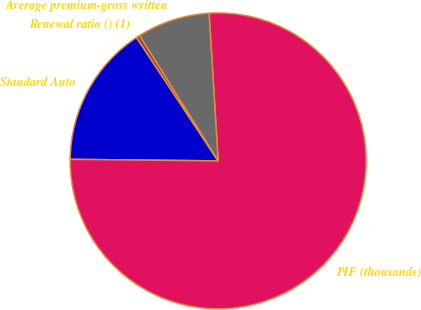Convert chart. <chart><loc_0><loc_0><loc_500><loc_500><pie_chart><fcel>Standard Auto<fcel>PIF (thousands)<fcel>Average premium-gross written<fcel>Renewal ratio () (1)<nl><fcel>15.53%<fcel>76.14%<fcel>7.95%<fcel>0.38%<nl></chart> 